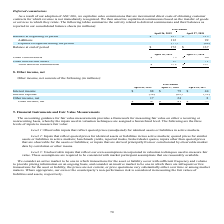From Netapp's financial document, Which years does the table provide information for? The document contains multiple relevant values: 2019, 2018, 2017. From the document: "April 26, 2019 April 27, 2018 April 28, 2017 April 26, 2019 April 27, 2018 April 28, 2017 April 26, 2019 April 27, 2018 April 28, 2017..." Also, What was the interest income in 2019? According to the financial document, 88 (in millions). The relevant text states: "Interest income $ 88 $ 79 $ 44..." Also, What was the interest expense in 2018? Based on the financial document, the answer is (62) (in millions). Also, How many years did interest income exceed $50 million? Counting the relevant items in the document: 2019, 2018, I find 2 instances. The key data points involved are: 2018, 2019. Also, can you calculate: What was the change in interest expense between 2017 and 2018? Based on the calculation: -62-(-52), the result is -10 (in millions). This is based on the information: "Interest expense (58 ) (62 ) (52 ) Interest expense (58 ) (62 ) (52 )..." The key data points involved are: 52, 62. Also, can you calculate: What was the percentage change in Interest income between 2018 and 2019? To answer this question, I need to perform calculations using the financial data. The calculation is: (88-79)/79, which equals 11.39 (percentage). This is based on the information: "Interest income $ 88 $ 79 $ 44 Interest income $ 88 $ 79 $ 44..." The key data points involved are: 79, 88. 